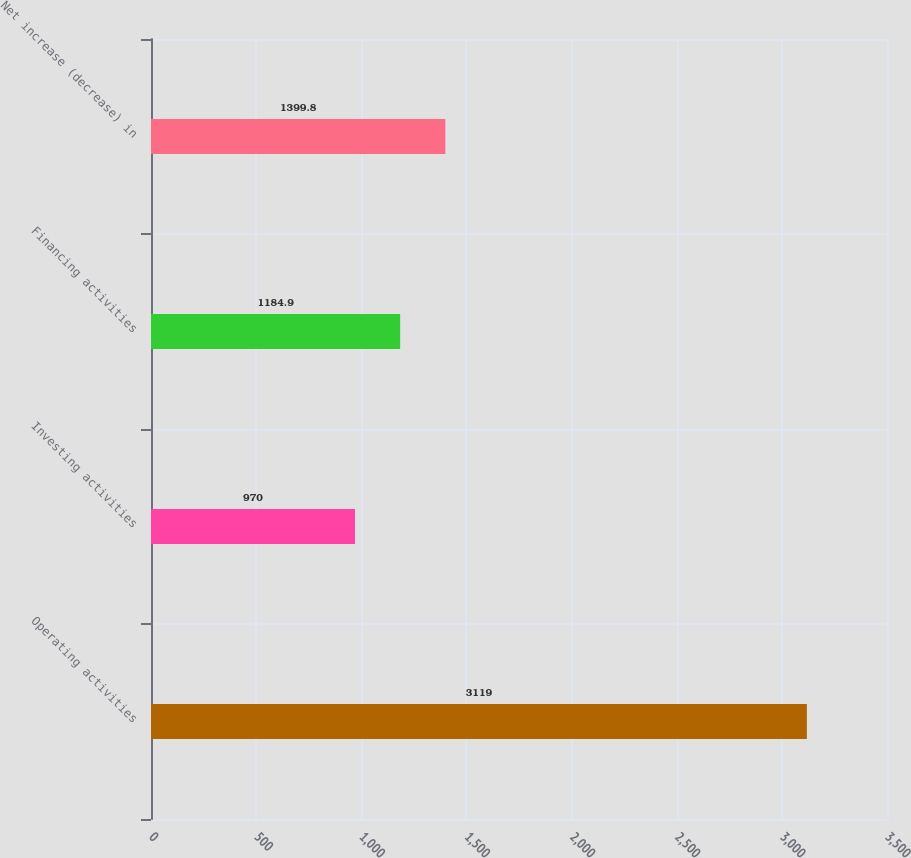Convert chart to OTSL. <chart><loc_0><loc_0><loc_500><loc_500><bar_chart><fcel>Operating activities<fcel>Investing activities<fcel>Financing activities<fcel>Net increase (decrease) in<nl><fcel>3119<fcel>970<fcel>1184.9<fcel>1399.8<nl></chart> 